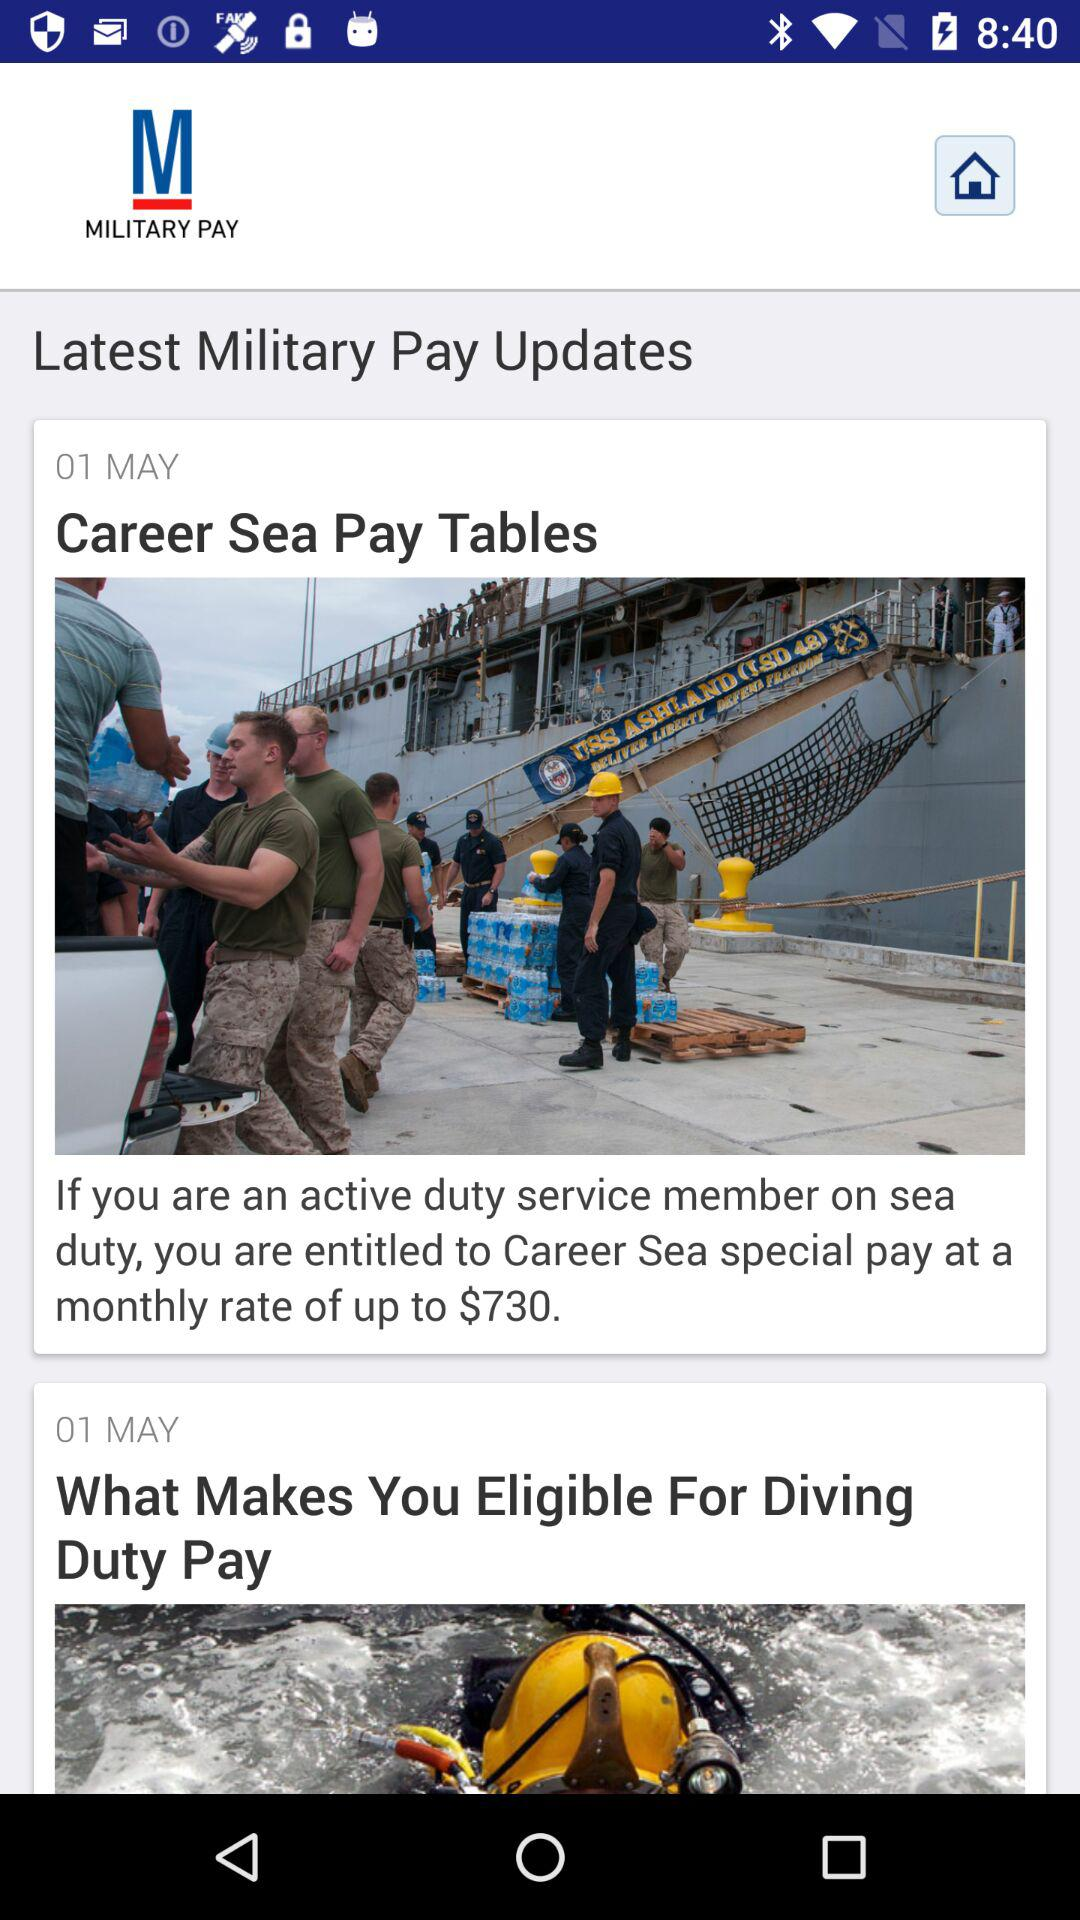At what monthly rate is the "Career Sea" special pay paid? The "Career Sea" special pay is paid at a monthly rate of up to 730 dollars. 